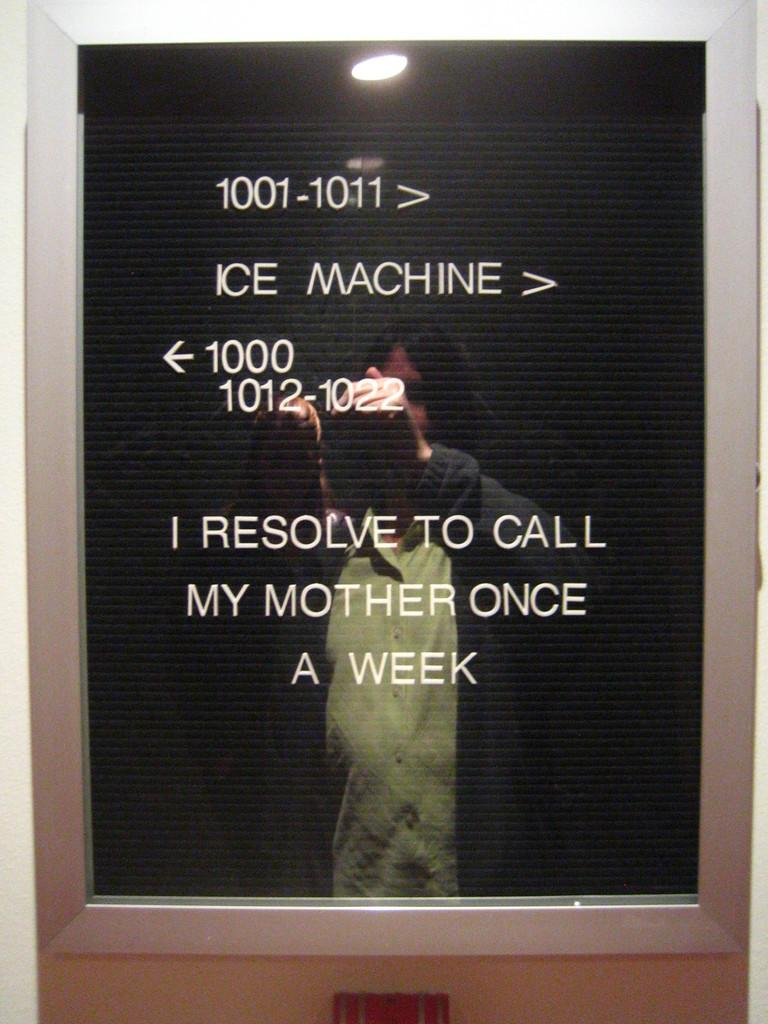Provide a one-sentence caption for the provided image. A sign directing hotel patrons to the ice machine. 